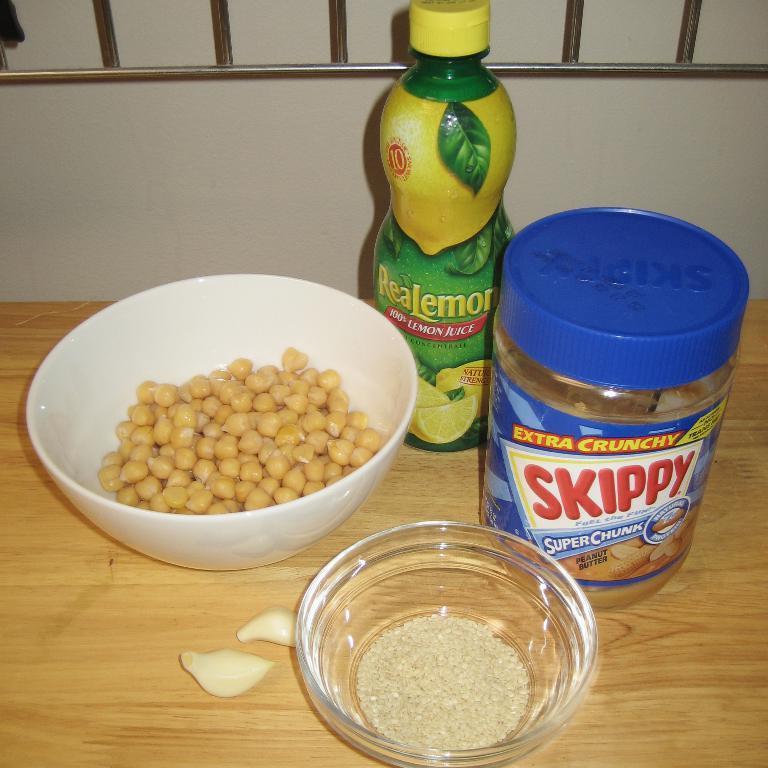Please provide a concise description of this image. In this image there is a table at bottom of this image and there are some bowls are kept on it and there two bottles are at right side of this image , and there is a wall in the background. 